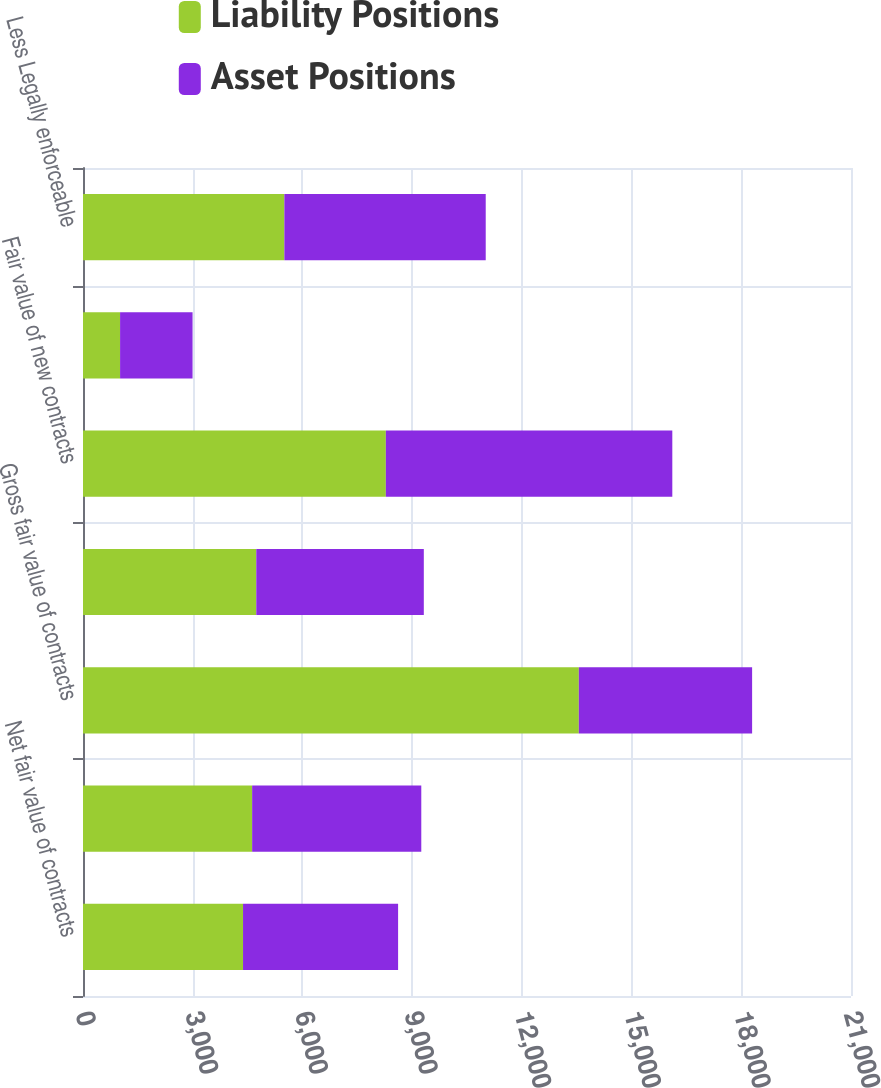Convert chart to OTSL. <chart><loc_0><loc_0><loc_500><loc_500><stacked_bar_chart><ecel><fcel>Net fair value of contracts<fcel>Effect of legally enforceable<fcel>Gross fair value of contracts<fcel>Contracts realized or<fcel>Fair value of new contracts<fcel>Other changes in fair value<fcel>Less Legally enforceable<nl><fcel>Liability Positions<fcel>4376<fcel>4625<fcel>13558<fcel>4738<fcel>8281<fcel>1014<fcel>5506<nl><fcel>Asset Positions<fcel>4240<fcel>4625<fcel>4738<fcel>4581<fcel>7833<fcel>1982<fcel>5506<nl></chart> 